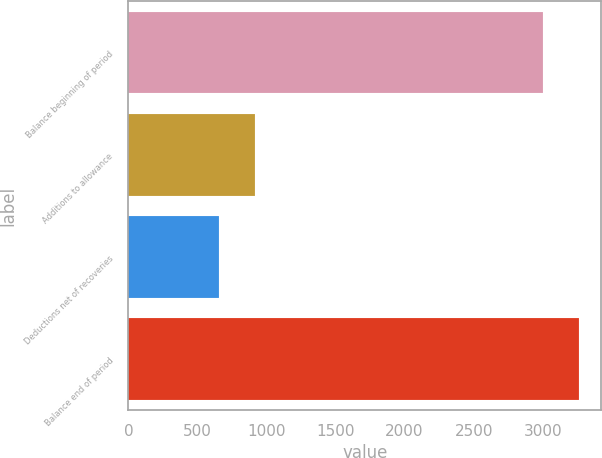Convert chart. <chart><loc_0><loc_0><loc_500><loc_500><bar_chart><fcel>Balance beginning of period<fcel>Additions to allowance<fcel>Deductions net of recoveries<fcel>Balance end of period<nl><fcel>3000<fcel>915.4<fcel>656<fcel>3259.4<nl></chart> 